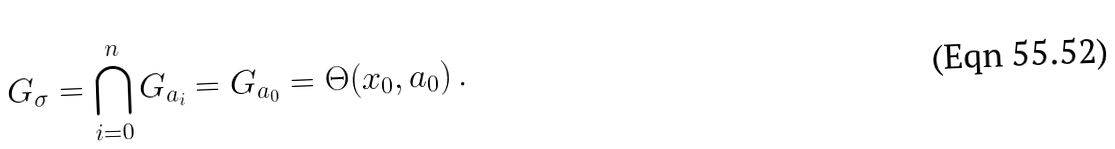Convert formula to latex. <formula><loc_0><loc_0><loc_500><loc_500>G _ { \sigma } = \bigcap _ { i = 0 } ^ { n } G _ { a _ { i } } = G _ { a _ { 0 } } = \Theta ( x _ { 0 } , a _ { 0 } ) \, .</formula> 